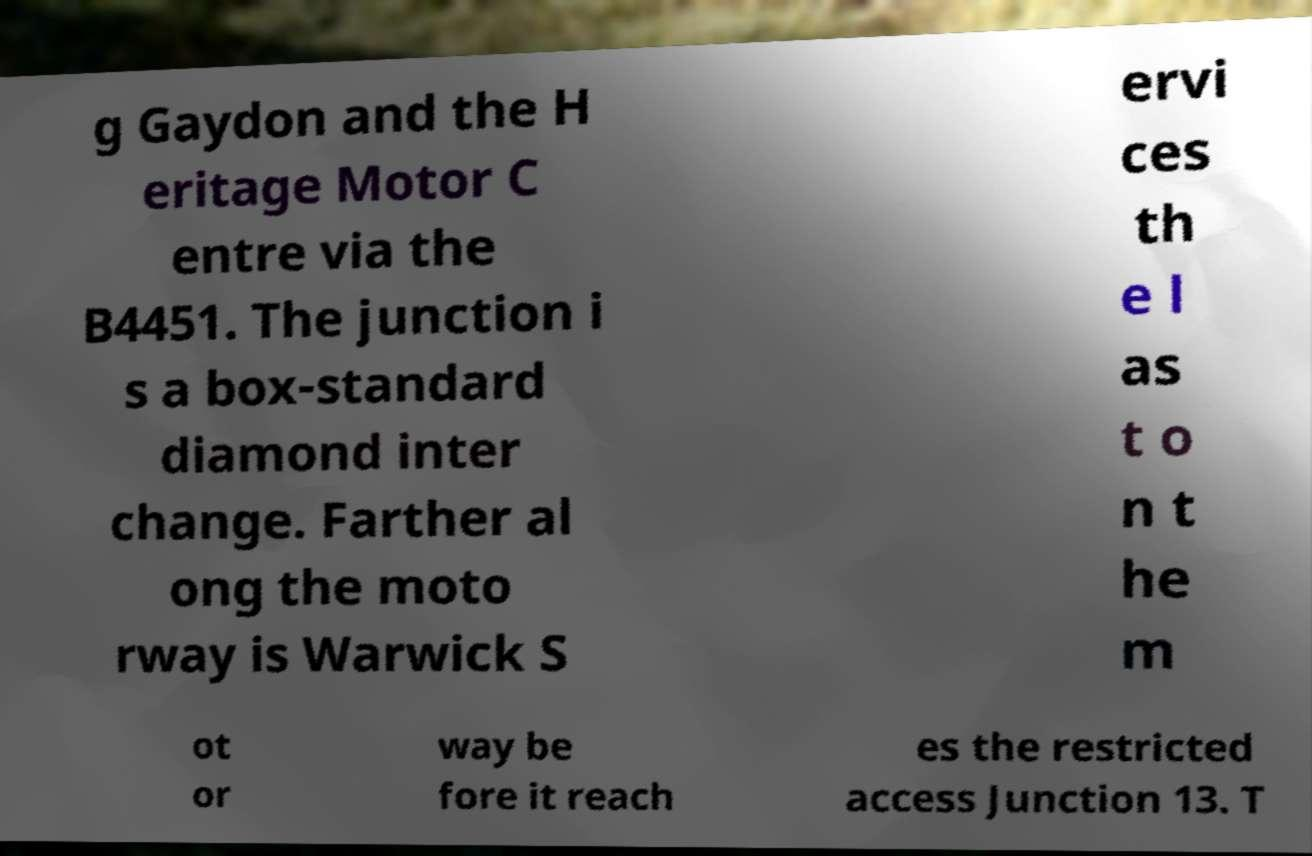There's text embedded in this image that I need extracted. Can you transcribe it verbatim? g Gaydon and the H eritage Motor C entre via the B4451. The junction i s a box-standard diamond inter change. Farther al ong the moto rway is Warwick S ervi ces th e l as t o n t he m ot or way be fore it reach es the restricted access Junction 13. T 